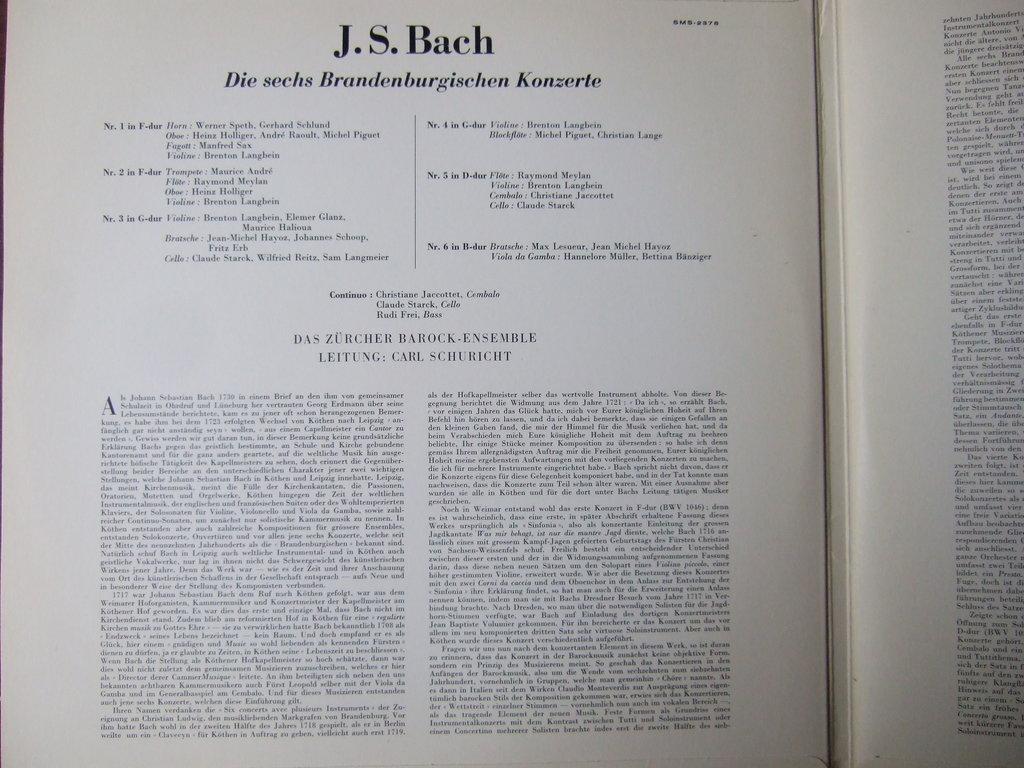Whos name is in large bold letters on the top of the page?
Make the answer very short. J.s. bach. 